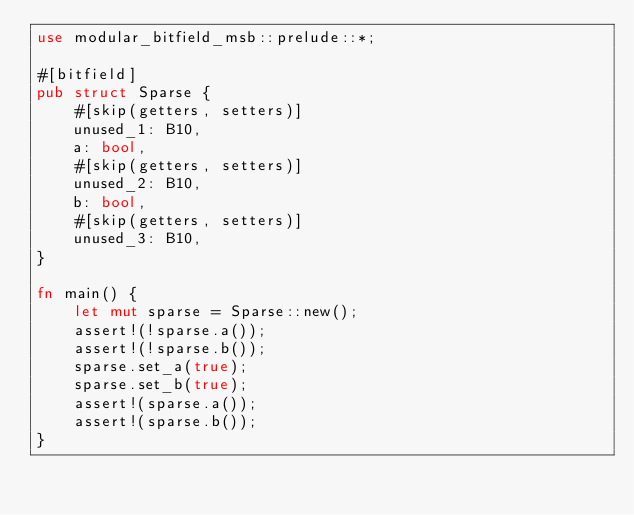Convert code to text. <code><loc_0><loc_0><loc_500><loc_500><_Rust_>use modular_bitfield_msb::prelude::*;

#[bitfield]
pub struct Sparse {
    #[skip(getters, setters)]
    unused_1: B10,
    a: bool,
    #[skip(getters, setters)]
    unused_2: B10,
    b: bool,
    #[skip(getters, setters)]
    unused_3: B10,
}

fn main() {
    let mut sparse = Sparse::new();
    assert!(!sparse.a());
    assert!(!sparse.b());
    sparse.set_a(true);
    sparse.set_b(true);
    assert!(sparse.a());
    assert!(sparse.b());
}
</code> 